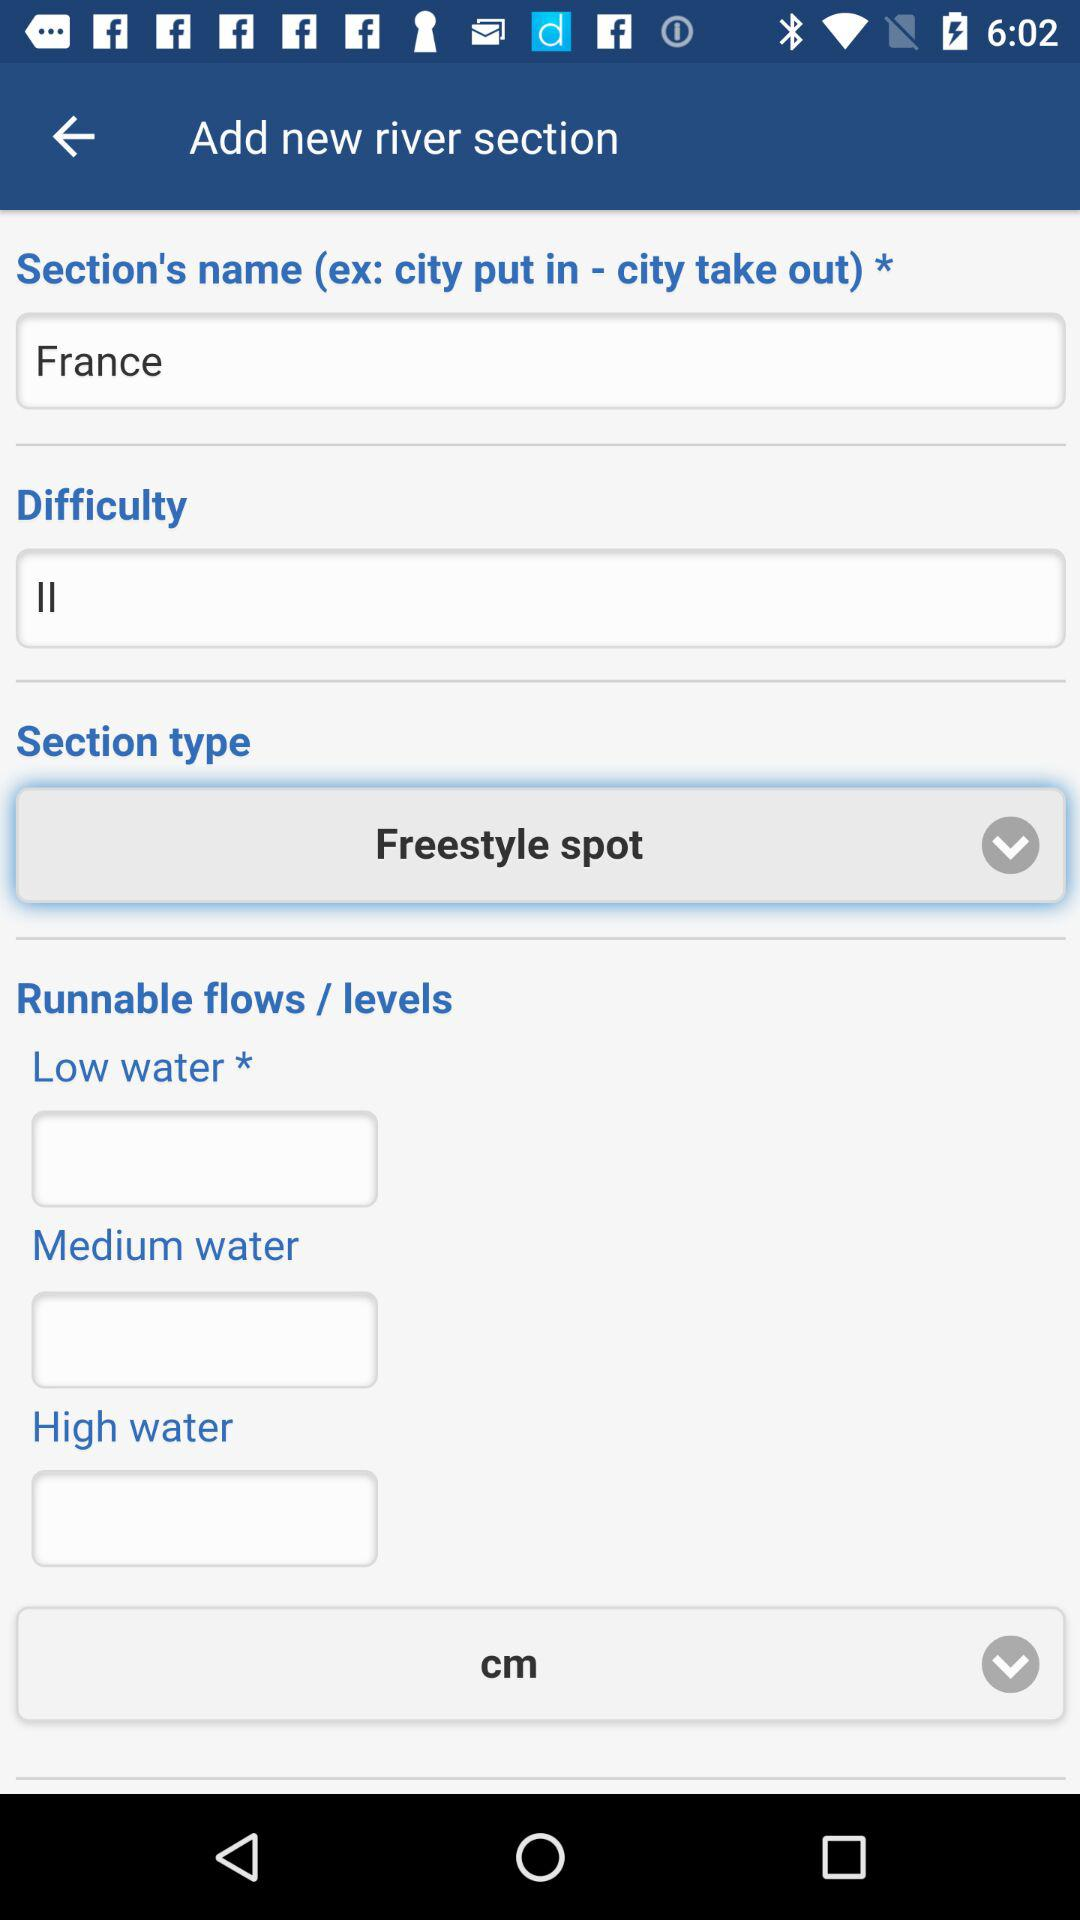How many more low water text inputs are there than high water text inputs?
Answer the question using a single word or phrase. 1 